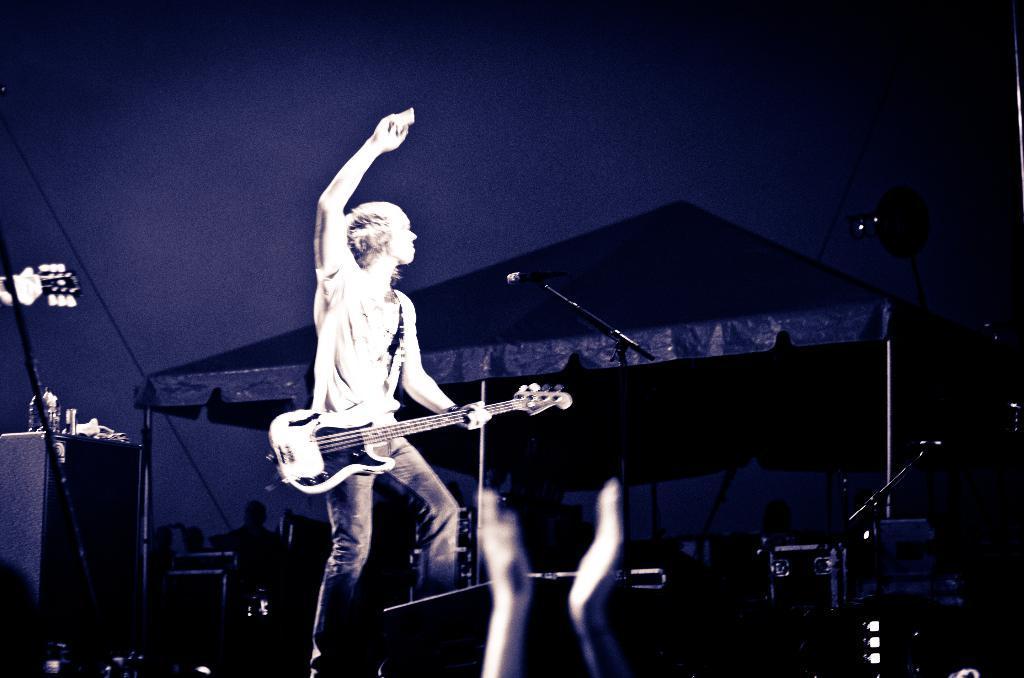Can you describe this image briefly? This picture shows a person playing a guitar in his hands standing in front of a microphone. In the background there is a tent. 